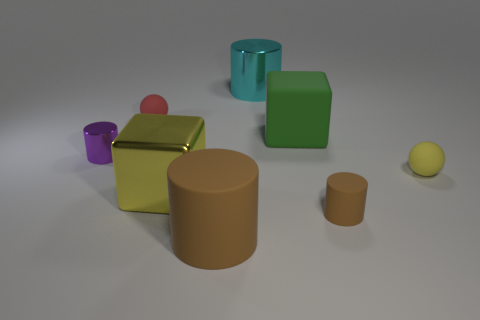Subtract all purple cylinders. How many cylinders are left? 3 Subtract all gray cylinders. Subtract all green blocks. How many cylinders are left? 4 Add 1 small red balls. How many objects exist? 9 Subtract all spheres. How many objects are left? 6 Add 5 red rubber things. How many red rubber things are left? 6 Add 6 big blocks. How many big blocks exist? 8 Subtract 1 brown cylinders. How many objects are left? 7 Subtract all yellow metallic things. Subtract all balls. How many objects are left? 5 